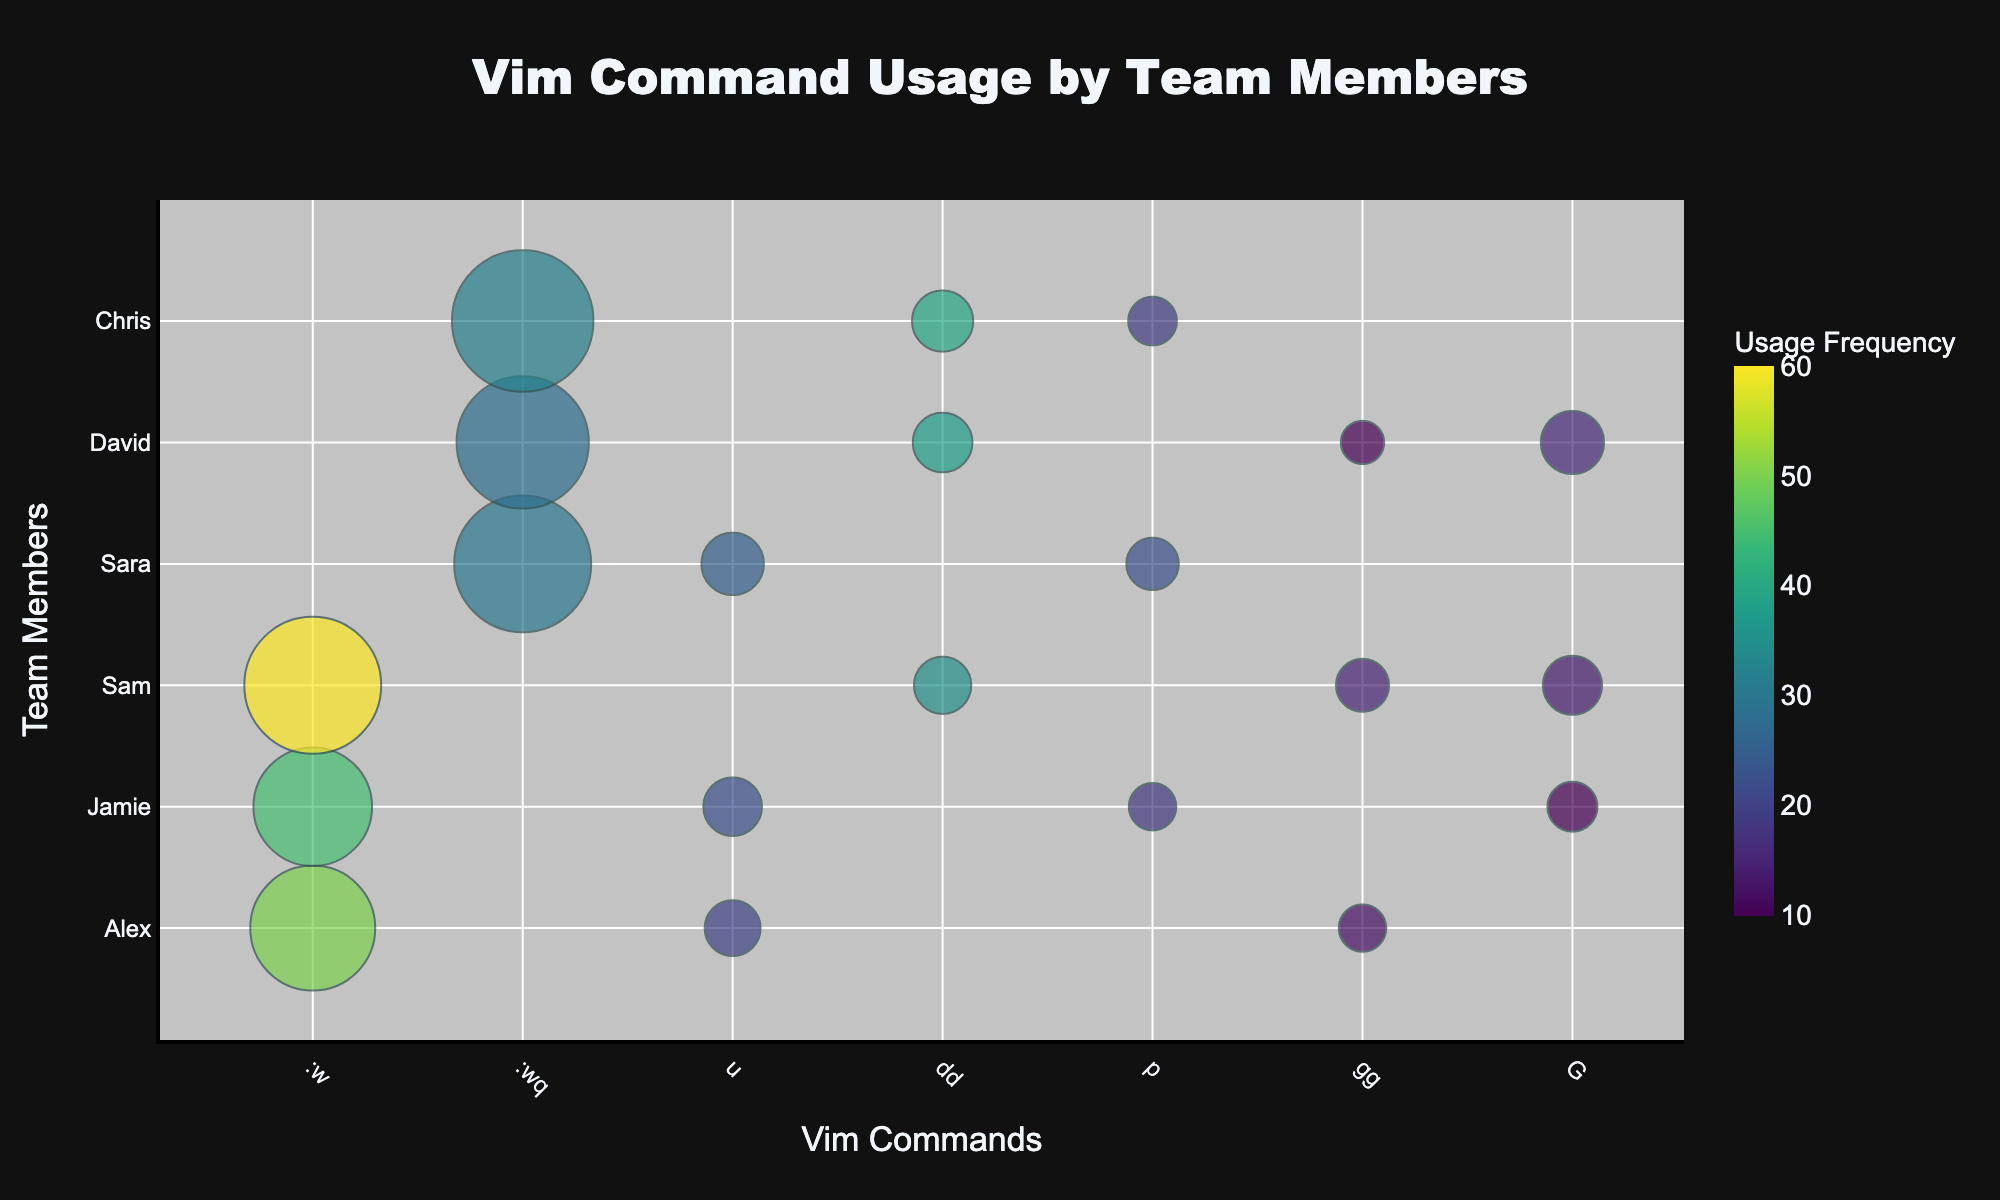What is the most frequently used command overall? To find the most frequently used command, look at the sum of the "Usage Frequency" values for each command across all team members. Calculate for each command, and find that :w has the highest total (50 + 45 + 60 = 155).
Answer: :w Which team member uses the :dd command the most? To determine the team member who uses the :dd command the most, compare the "Usage Frequency" for the :dd command for each team member. Chris has 40, Sam has 35, and David has 38. Thus, Chris has the highest usage.
Answer: Chris How do the usage frequencies of the :w and :wq commands compare for Sara? Look at Sara’s usage frequency values for both commands. Sara has used :wq 30 times and does not have a value for :w, indicating that :wq is used more frequently by her.
Answer: :wq Which team member spends the most time on the :u command and how much time is that? For the :u command, the durations are the same for all instances. Compare the total usage duration by multiplying :u's "Usage Frequency" by "Duration (seconds)" for each team member. Sara's usage frequency is 25, and the duration is 0.5 seconds, leading to a total of 25 * 0.5 = 12.5 seconds, the highest among the team members.
Answer: Sara, 12.5 seconds On average, how often does Jamie use commands compared to David? Calculate the usage frequency totals for Jamie (45 for :w, 22 for :u, 18 for :p, 10 for :G) = 45 + 22 + 18 + 10 = 95. For David (28 for :wq, 38 for :dd, 10 for :gg, 16 for :G) = 28 + 38 + 10 + 16 = 92. Then find their average usage by dividing the totals by the number of commands they use (Jamie: 4 commands, David: 4 commands). 95/4 is 23.75 for Jamie and 92/4 is 23 for David.
Answer: Jamie: 23.75, David: 23 Which commands did Alex use, and what are their usage frequencies? Look at Alex’s usage frequency values for each command. Alex used :w 50 times, :u 20 times, and :gg 12 times. These are the commands used by Alex with their respective frequencies.
Answer: :w: 50, :u: 20, :gg: 12 Which team member has the most consistent usage frequency across all commands they use? To determine consistency, calculate the range (difference between the highest and lowest usage frequency) for each team member. The smallest range indicates the most consistent usage. Alex’s commands have frequencies of 50, 20, and 12 (range: 50-12=38); Jamie’s 45, 22, 18, 10 (range: 45-10=35); Sam’s 60, 35, 15, 14 (range: 60-14=46); Sara’s 30, 25, 22 (range: 30-22=8); David’s 28, 38, 10, 16 (range: 38-10=28); Chris’s 32, 40, 19 (range: 40-19=21). Sara has the smallest range.
Answer: Sara Which Vim command is used the least frequently and by whom? Find the lowest usage frequency across all commands and team members. The "gg" command used by David and Alex has the lowest frequencies at 10. Check the team members for usage; David and Alex both have a frequency of 10 for "gg".
Answer: gg, David and Alex How does the total usage frequency of :p compare to :G? Sum the usage frequencies of the :p command for all relevant team members: Jamie (18), Sara (22), Chris (19) = 18 + 22 + 19 = 59. For the :G command: Sam (14), David (16), Jamie (10) = 14 + 16 + 10 = 40. Compare these totals: 59 for :p and 40 for :G.
Answer: :p uses 59, :G uses 40 